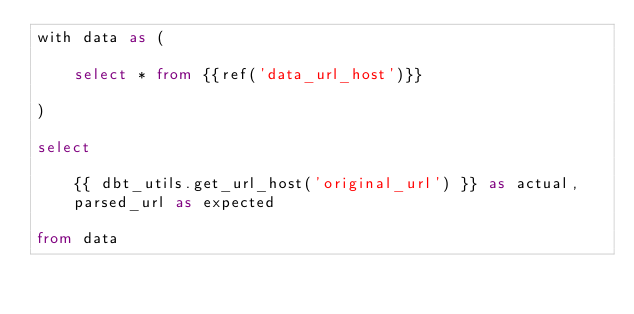Convert code to text. <code><loc_0><loc_0><loc_500><loc_500><_SQL_>with data as (
    
    select * from {{ref('data_url_host')}}
    
)

select

    {{ dbt_utils.get_url_host('original_url') }} as actual,
    parsed_url as expected
    
from data</code> 